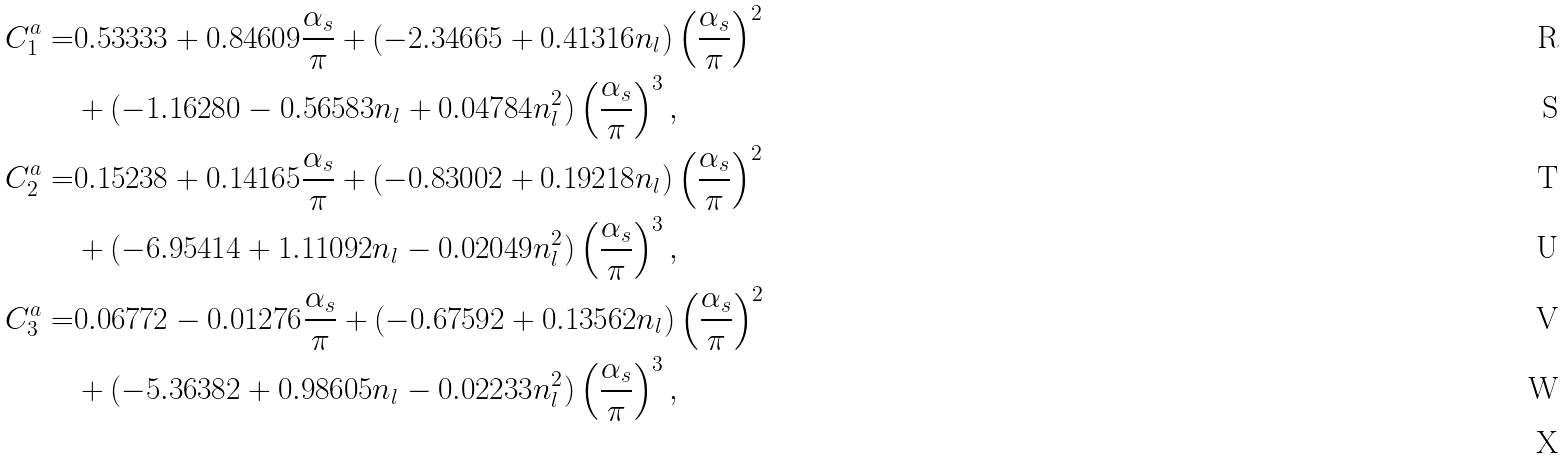Convert formula to latex. <formula><loc_0><loc_0><loc_500><loc_500>C _ { 1 } ^ { a } = & 0 . 5 3 3 3 3 + 0 . 8 4 6 0 9 \frac { \alpha _ { s } } { \pi } + ( - 2 . 3 4 6 6 5 + 0 . 4 1 3 1 6 n _ { l } ) \left ( \frac { \alpha _ { s } } { \pi } \right ) ^ { 2 } \\ & + ( - 1 . 1 6 2 8 0 - 0 . 5 6 5 8 3 n _ { l } + 0 . 0 4 7 8 4 n _ { l } ^ { 2 } ) \left ( \frac { \alpha _ { s } } { \pi } \right ) ^ { 3 } , \\ C _ { 2 } ^ { a } = & 0 . 1 5 2 3 8 + 0 . 1 4 1 6 5 \frac { \alpha _ { s } } { \pi } + ( - 0 . 8 3 0 0 2 + 0 . 1 9 2 1 8 n _ { l } ) \left ( \frac { \alpha _ { s } } { \pi } \right ) ^ { 2 } \\ & + ( - 6 . 9 5 4 1 4 + 1 . 1 1 0 9 2 n _ { l } - 0 . 0 2 0 4 9 n _ { l } ^ { 2 } ) \left ( \frac { \alpha _ { s } } { \pi } \right ) ^ { 3 } , \\ C _ { 3 } ^ { a } = & 0 . 0 6 7 7 2 - 0 . 0 1 2 7 6 \frac { \alpha _ { s } } { \pi } + ( - 0 . 6 7 5 9 2 + 0 . 1 3 5 6 2 n _ { l } ) \left ( \frac { \alpha _ { s } } { \pi } \right ) ^ { 2 } \\ & + ( - 5 . 3 6 3 8 2 + 0 . 9 8 6 0 5 n _ { l } - 0 . 0 2 2 3 3 n _ { l } ^ { 2 } ) \left ( \frac { \alpha _ { s } } { \pi } \right ) ^ { 3 } , \\</formula> 